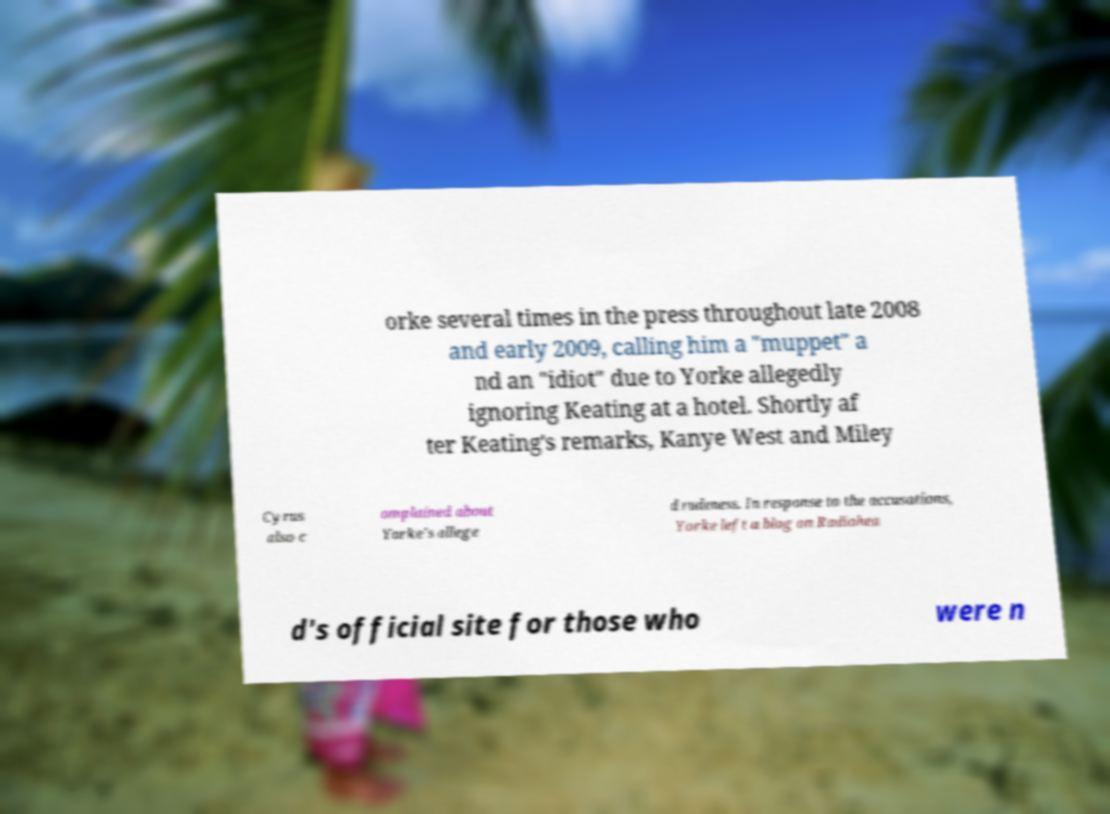For documentation purposes, I need the text within this image transcribed. Could you provide that? orke several times in the press throughout late 2008 and early 2009, calling him a "muppet" a nd an "idiot" due to Yorke allegedly ignoring Keating at a hotel. Shortly af ter Keating's remarks, Kanye West and Miley Cyrus also c omplained about Yorke's allege d rudeness. In response to the accusations, Yorke left a blog on Radiohea d's official site for those who were n 